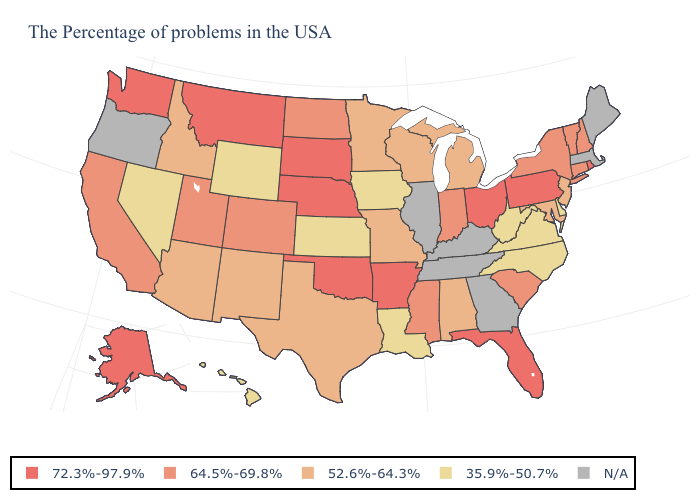Does the first symbol in the legend represent the smallest category?
Short answer required. No. Does the map have missing data?
Keep it brief. Yes. Name the states that have a value in the range 52.6%-64.3%?
Answer briefly. New Jersey, Maryland, Michigan, Alabama, Wisconsin, Missouri, Minnesota, Texas, New Mexico, Arizona, Idaho. Name the states that have a value in the range 72.3%-97.9%?
Quick response, please. Rhode Island, Pennsylvania, Ohio, Florida, Arkansas, Nebraska, Oklahoma, South Dakota, Montana, Washington, Alaska. What is the value of North Dakota?
Give a very brief answer. 64.5%-69.8%. Which states have the highest value in the USA?
Write a very short answer. Rhode Island, Pennsylvania, Ohio, Florida, Arkansas, Nebraska, Oklahoma, South Dakota, Montana, Washington, Alaska. Among the states that border Texas , does Arkansas have the lowest value?
Keep it brief. No. Which states have the lowest value in the USA?
Give a very brief answer. Delaware, Virginia, North Carolina, West Virginia, Louisiana, Iowa, Kansas, Wyoming, Nevada, Hawaii. What is the value of Rhode Island?
Answer briefly. 72.3%-97.9%. What is the lowest value in states that border Vermont?
Short answer required. 64.5%-69.8%. Name the states that have a value in the range 52.6%-64.3%?
Concise answer only. New Jersey, Maryland, Michigan, Alabama, Wisconsin, Missouri, Minnesota, Texas, New Mexico, Arizona, Idaho. Does West Virginia have the lowest value in the USA?
Keep it brief. Yes. What is the value of Arkansas?
Concise answer only. 72.3%-97.9%. 